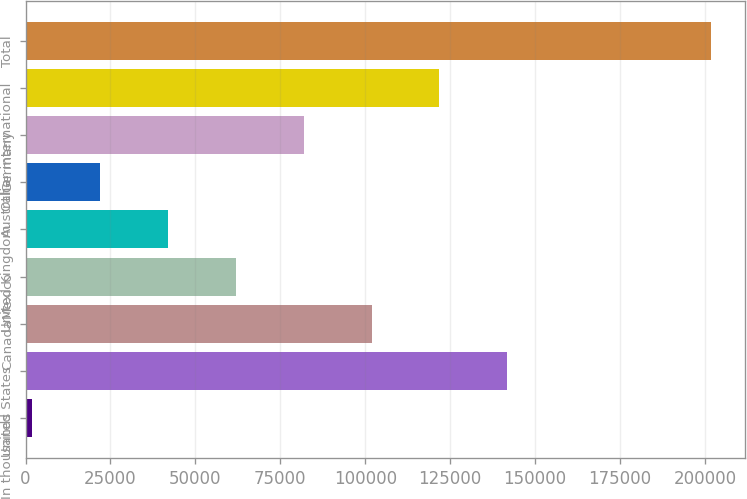<chart> <loc_0><loc_0><loc_500><loc_500><bar_chart><fcel>In thousands<fcel>United States<fcel>Canada<fcel>Mexico<fcel>United Kingdom<fcel>Australia<fcel>Germany<fcel>Other international<fcel>Total<nl><fcel>2009<fcel>141798<fcel>101858<fcel>61918.4<fcel>41948.6<fcel>21978.8<fcel>81888.2<fcel>121828<fcel>201707<nl></chart> 